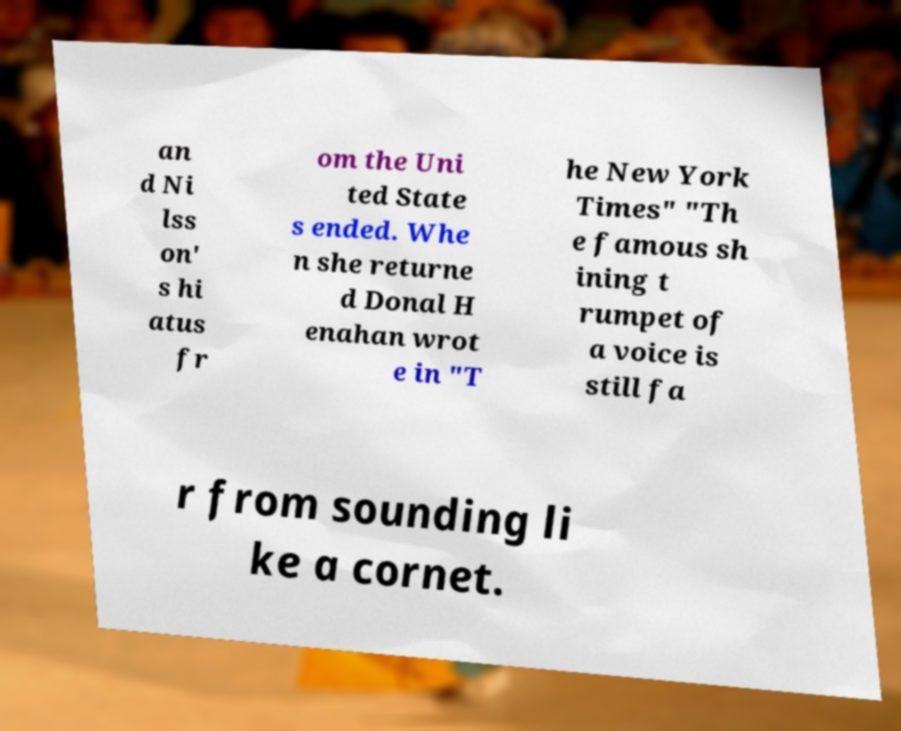Can you accurately transcribe the text from the provided image for me? an d Ni lss on' s hi atus fr om the Uni ted State s ended. Whe n she returne d Donal H enahan wrot e in "T he New York Times" "Th e famous sh ining t rumpet of a voice is still fa r from sounding li ke a cornet. 